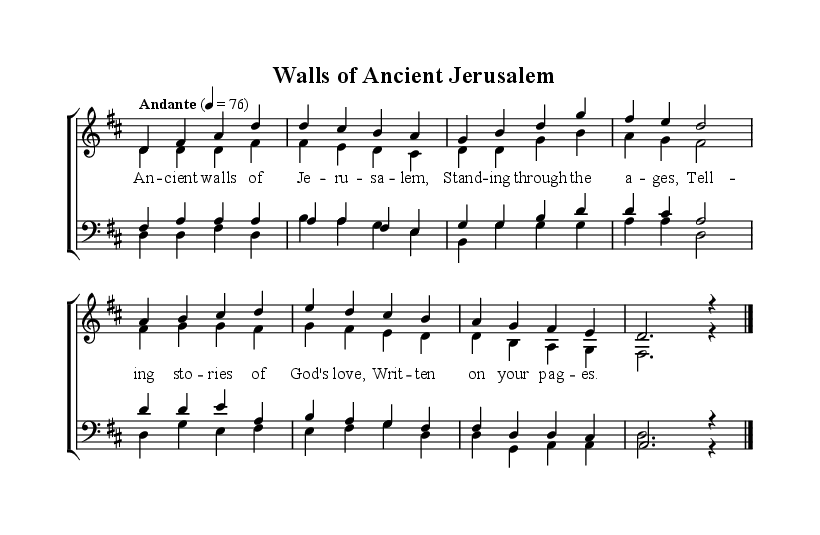What is the key signature of this music? The key signature is D major, which has two sharps (F# and C#). This is determined by looking at the key signature section at the beginning of the staff, where D major is indicated with the appropriate number of sharps.
Answer: D major What is the time signature of this music? The time signature is 4/4, which indicates that there are four beats per measure and a quarter note receives one beat. This can be found at the beginning of the first staff where the time signature is displayed.
Answer: 4/4 What is the tempo marking for this music? The tempo marking is Andante, which suggests a moderately slow tempo. This is noted above the staff, indicating the speed at which the music should be played.
Answer: Andante How many vocal parts are present in the score? There are four vocal parts present in the score, which can be identified by the four distinct voices labeled as melody, alto, tenor, and bass. Each part is notated separately in the score.
Answer: Four What is the name of the piece represented in the sheet music? The name of the piece is "Walls of Ancient Jerusalem," which is indicated in the header section of the score. The title provides the identity of the composition and its thematic focus.
Answer: Walls of Ancient Jerusalem What lyrical theme is presented in the first verse? The lyrical theme in the first verse reflects on the ancient walls of Jerusalem and their historical significance in relation to God's love and stories. This can be inferred from the lyrics presented beneath the melody.
Answer: Ancient walls of Jerusalem What is the ending note of the melody in this score? The ending note of the melody is D, which can be identified at the end of the melody line where the last note is located. This note concludes the piece.
Answer: D 